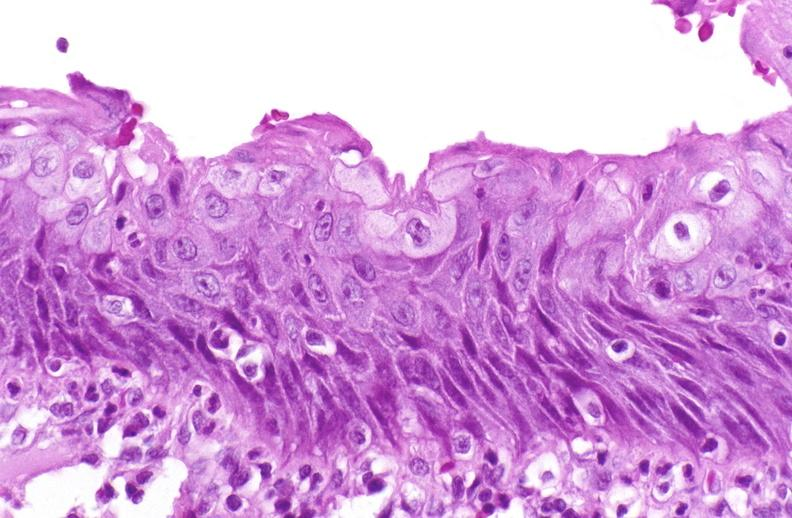does this image show squamous metaplasia, renal pelvis due to nephrolithiasis?
Answer the question using a single word or phrase. Yes 